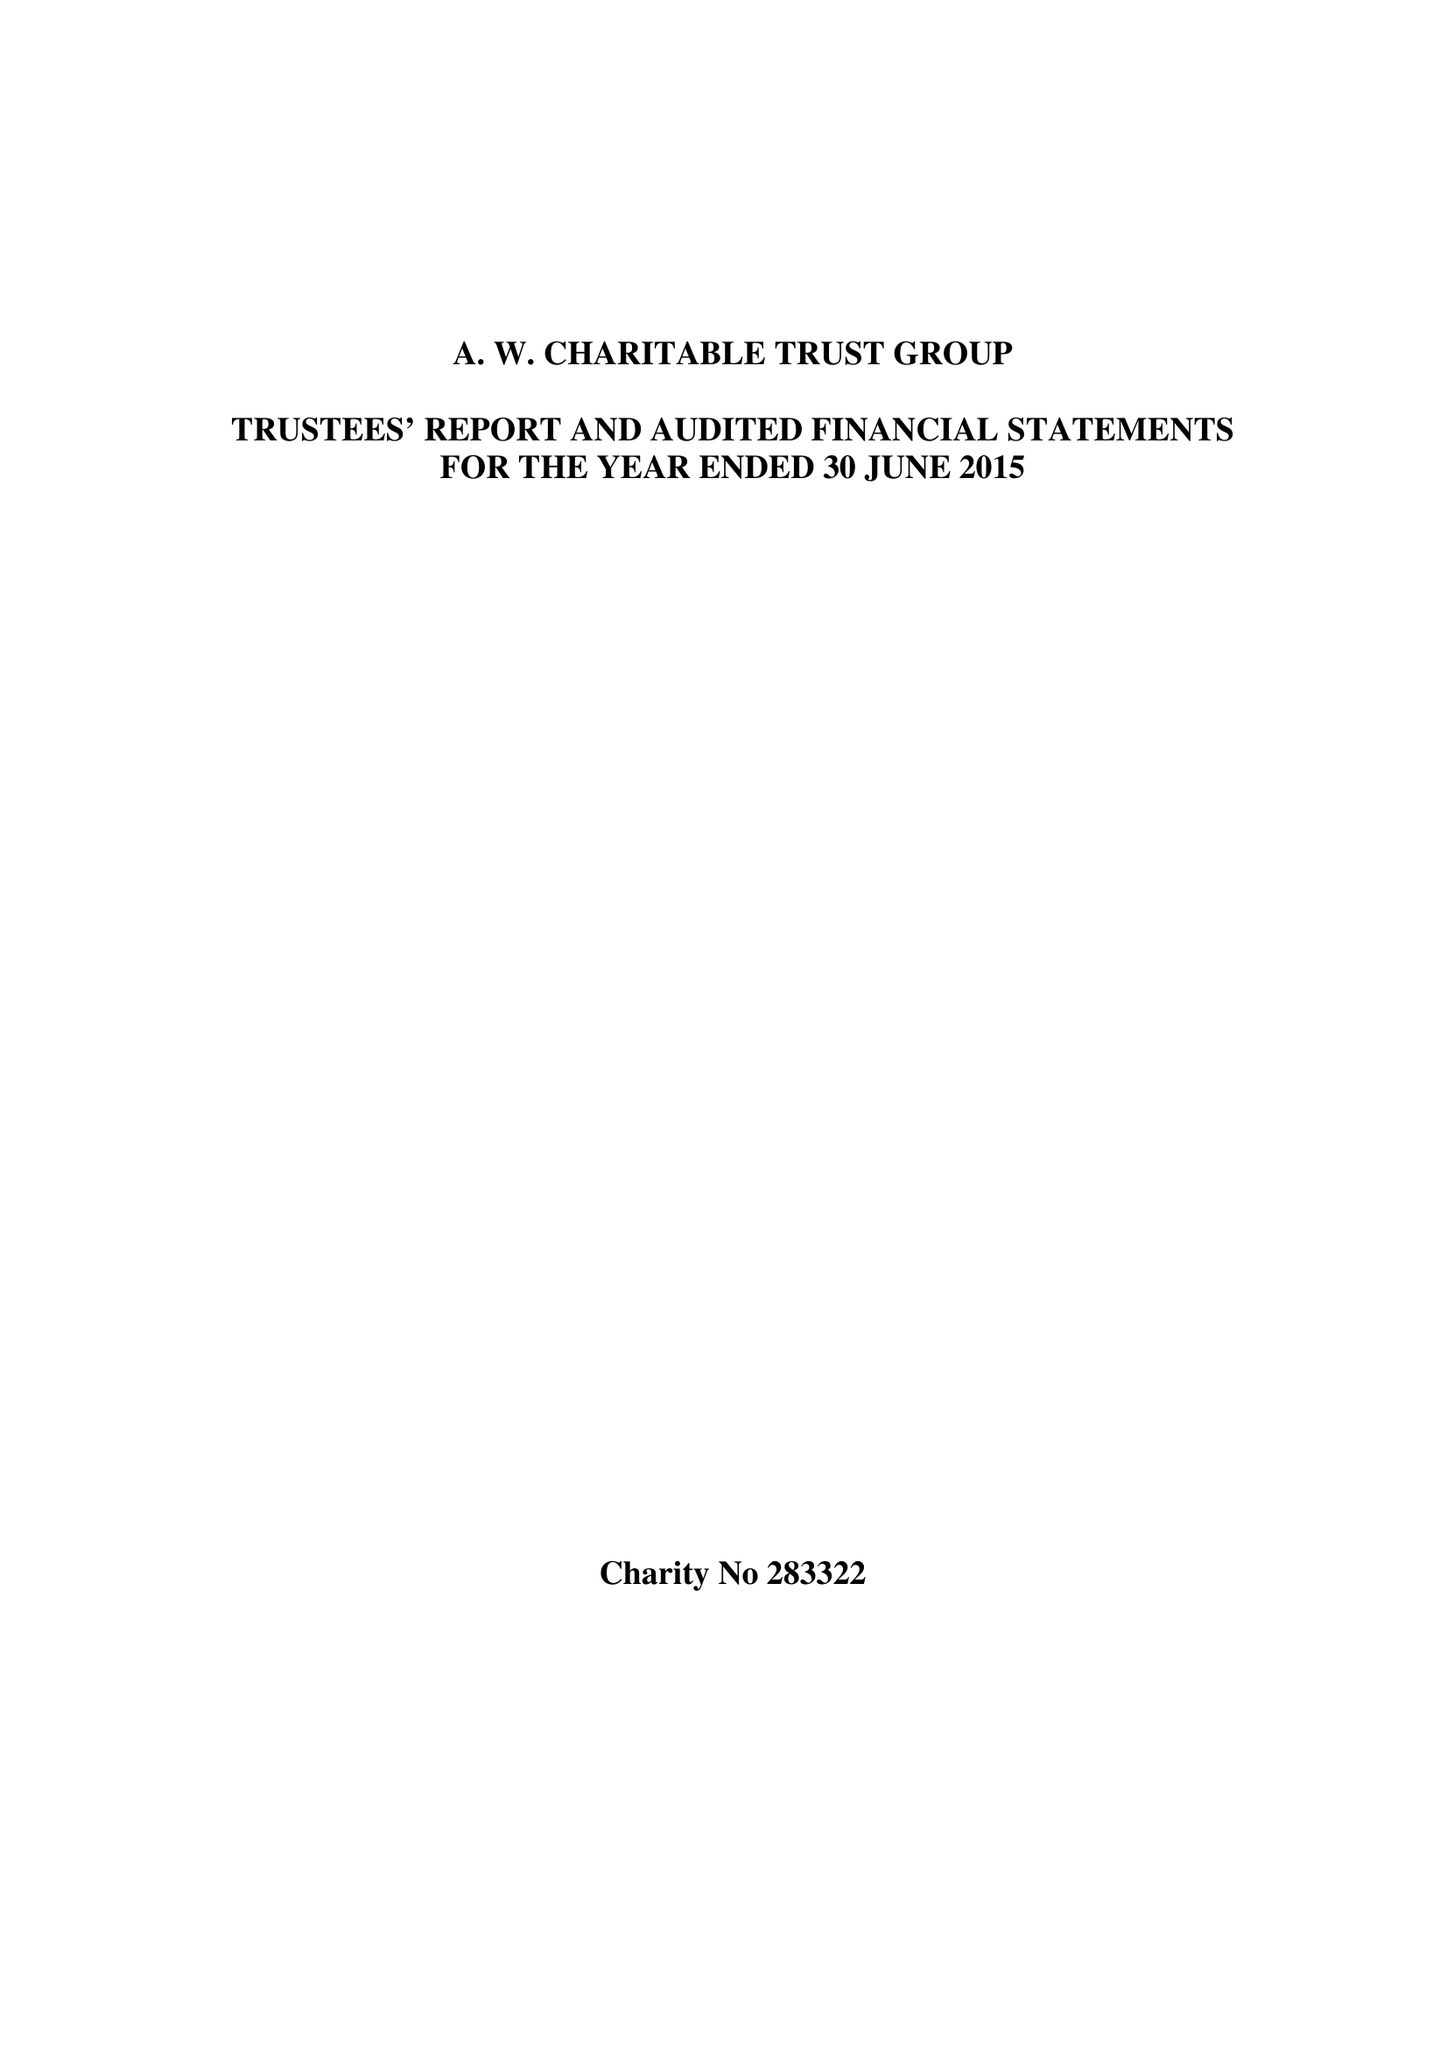What is the value for the address__post_town?
Answer the question using a single word or phrase. None 